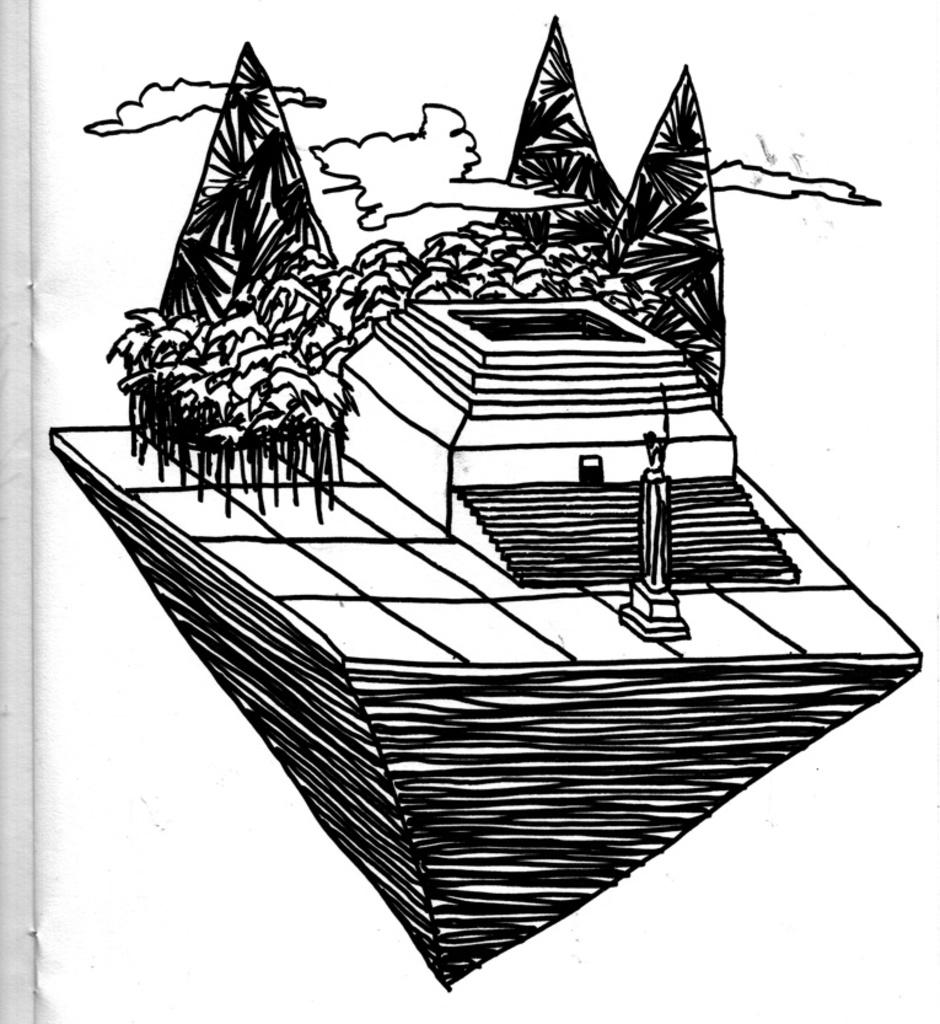What is depicted in the book in the image? The image contains a design in a book. What elements are included in the design? The design includes a mountain, trees, stairs, statues, and clouds. How many boots are visible in the design? There are no boots present in the design; it includes a mountain, trees, stairs, statues, and clouds. Can you hear the snakes crying in the image? There are no snakes or crying sounds present in the image; it features a design with a mountain, trees, stairs, statues, and clouds. 